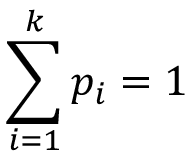<formula> <loc_0><loc_0><loc_500><loc_500>\sum _ { i = 1 } ^ { k } p _ { i } = 1</formula> 